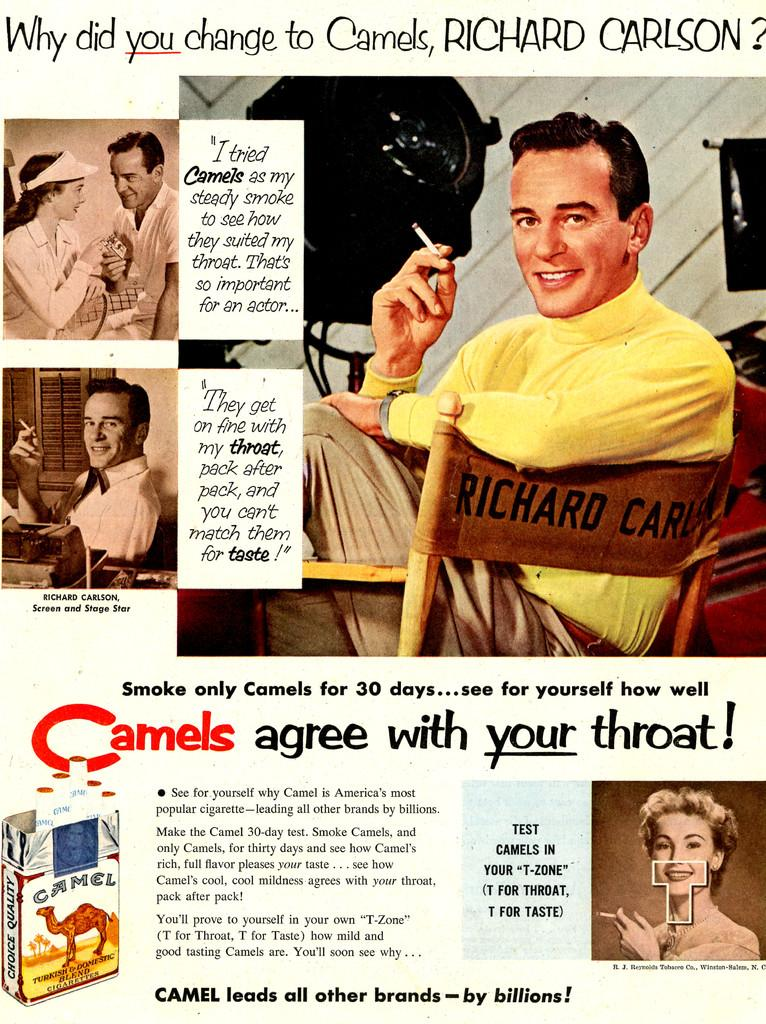<image>
Describe the image concisely. An old magazine advertisment for Camel Cigarettes with an image of a man smoking. 